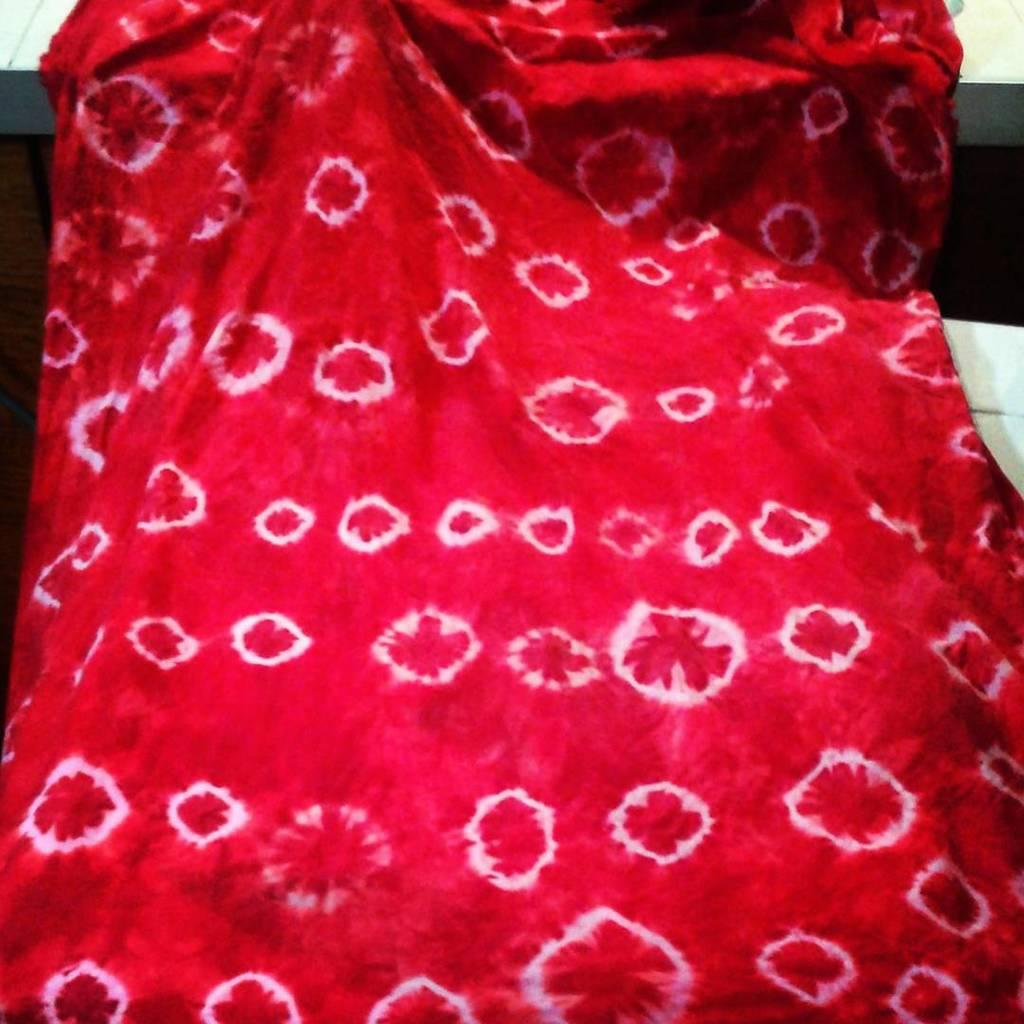What color of cloth is visible in the image? There is a red color of cloth in the image. Is there a coat made of the red cloth in the image? There is no mention of a coat or any specific type of clothing made from the red cloth in the image. 